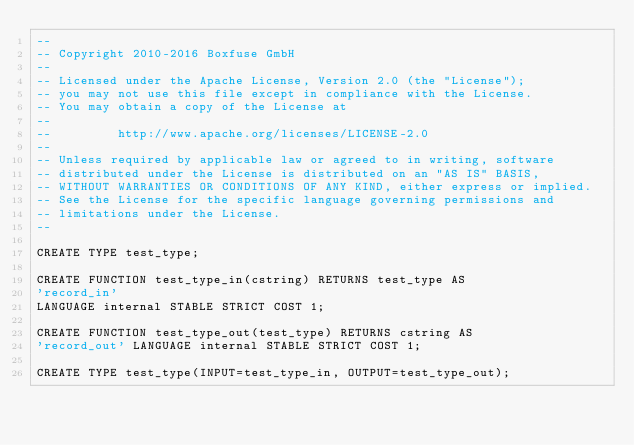<code> <loc_0><loc_0><loc_500><loc_500><_SQL_>--
-- Copyright 2010-2016 Boxfuse GmbH
--
-- Licensed under the Apache License, Version 2.0 (the "License");
-- you may not use this file except in compliance with the License.
-- You may obtain a copy of the License at
--
--         http://www.apache.org/licenses/LICENSE-2.0
--
-- Unless required by applicable law or agreed to in writing, software
-- distributed under the License is distributed on an "AS IS" BASIS,
-- WITHOUT WARRANTIES OR CONDITIONS OF ANY KIND, either express or implied.
-- See the License for the specific language governing permissions and
-- limitations under the License.
--

CREATE TYPE test_type;

CREATE FUNCTION test_type_in(cstring) RETURNS test_type AS
'record_in'
LANGUAGE internal STABLE STRICT COST 1;

CREATE FUNCTION test_type_out(test_type) RETURNS cstring AS
'record_out' LANGUAGE internal STABLE STRICT COST 1;

CREATE TYPE test_type(INPUT=test_type_in, OUTPUT=test_type_out);</code> 